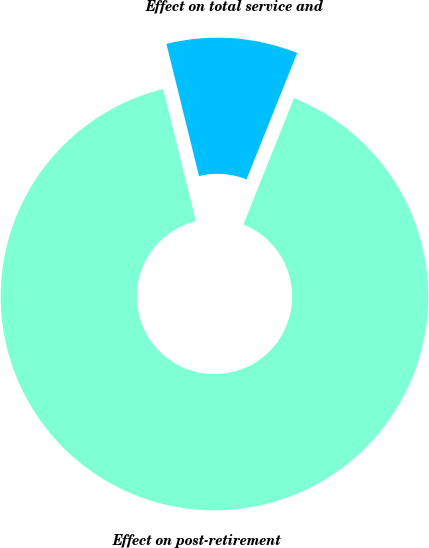Convert chart. <chart><loc_0><loc_0><loc_500><loc_500><pie_chart><fcel>Effect on total service and<fcel>Effect on post-retirement<nl><fcel>9.92%<fcel>90.08%<nl></chart> 